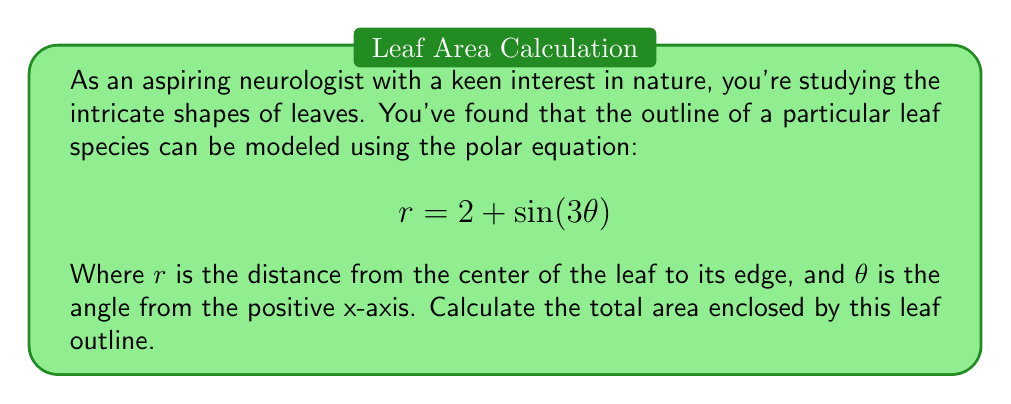Teach me how to tackle this problem. To find the area enclosed by a polar curve, we can use the formula:

$$A = \frac{1}{2} \int_{0}^{2\pi} r^2 d\theta$$

Let's break this down step-by-step:

1) First, we need to square our $r$ equation:
   $$r^2 = (2 + \sin(3\theta))^2 = 4 + 4\sin(3\theta) + \sin^2(3\theta)$$

2) Now, we can set up our integral:
   $$A = \frac{1}{2} \int_{0}^{2\pi} (4 + 4\sin(3\theta) + \sin^2(3\theta)) d\theta$$

3) Let's integrate each term separately:
   
   a) $\int_{0}^{2\pi} 4 d\theta = 4\theta \big|_{0}^{2\pi} = 8\pi$
   
   b) $\int_{0}^{2\pi} 4\sin(3\theta) d\theta = -\frac{4}{3}\cos(3\theta) \big|_{0}^{2\pi} = 0$
   
   c) For $\int_{0}^{2\pi} \sin^2(3\theta) d\theta$, we can use the identity $\sin^2(x) = \frac{1-\cos(2x)}{2}$:
      
      $\int_{0}^{2\pi} \sin^2(3\theta) d\theta = \int_{0}^{2\pi} \frac{1-\cos(6\theta)}{2} d\theta$
      
      $= \frac{1}{2}\theta - \frac{1}{12}\sin(6\theta) \big|_{0}^{2\pi} = \pi$

4) Adding these results:
   $$A = \frac{1}{2}(8\pi + 0 + \pi) = \frac{9\pi}{2}$$

Thus, the total area enclosed by the leaf outline is $\frac{9\pi}{2}$ square units.
Answer: $\frac{9\pi}{2}$ square units 